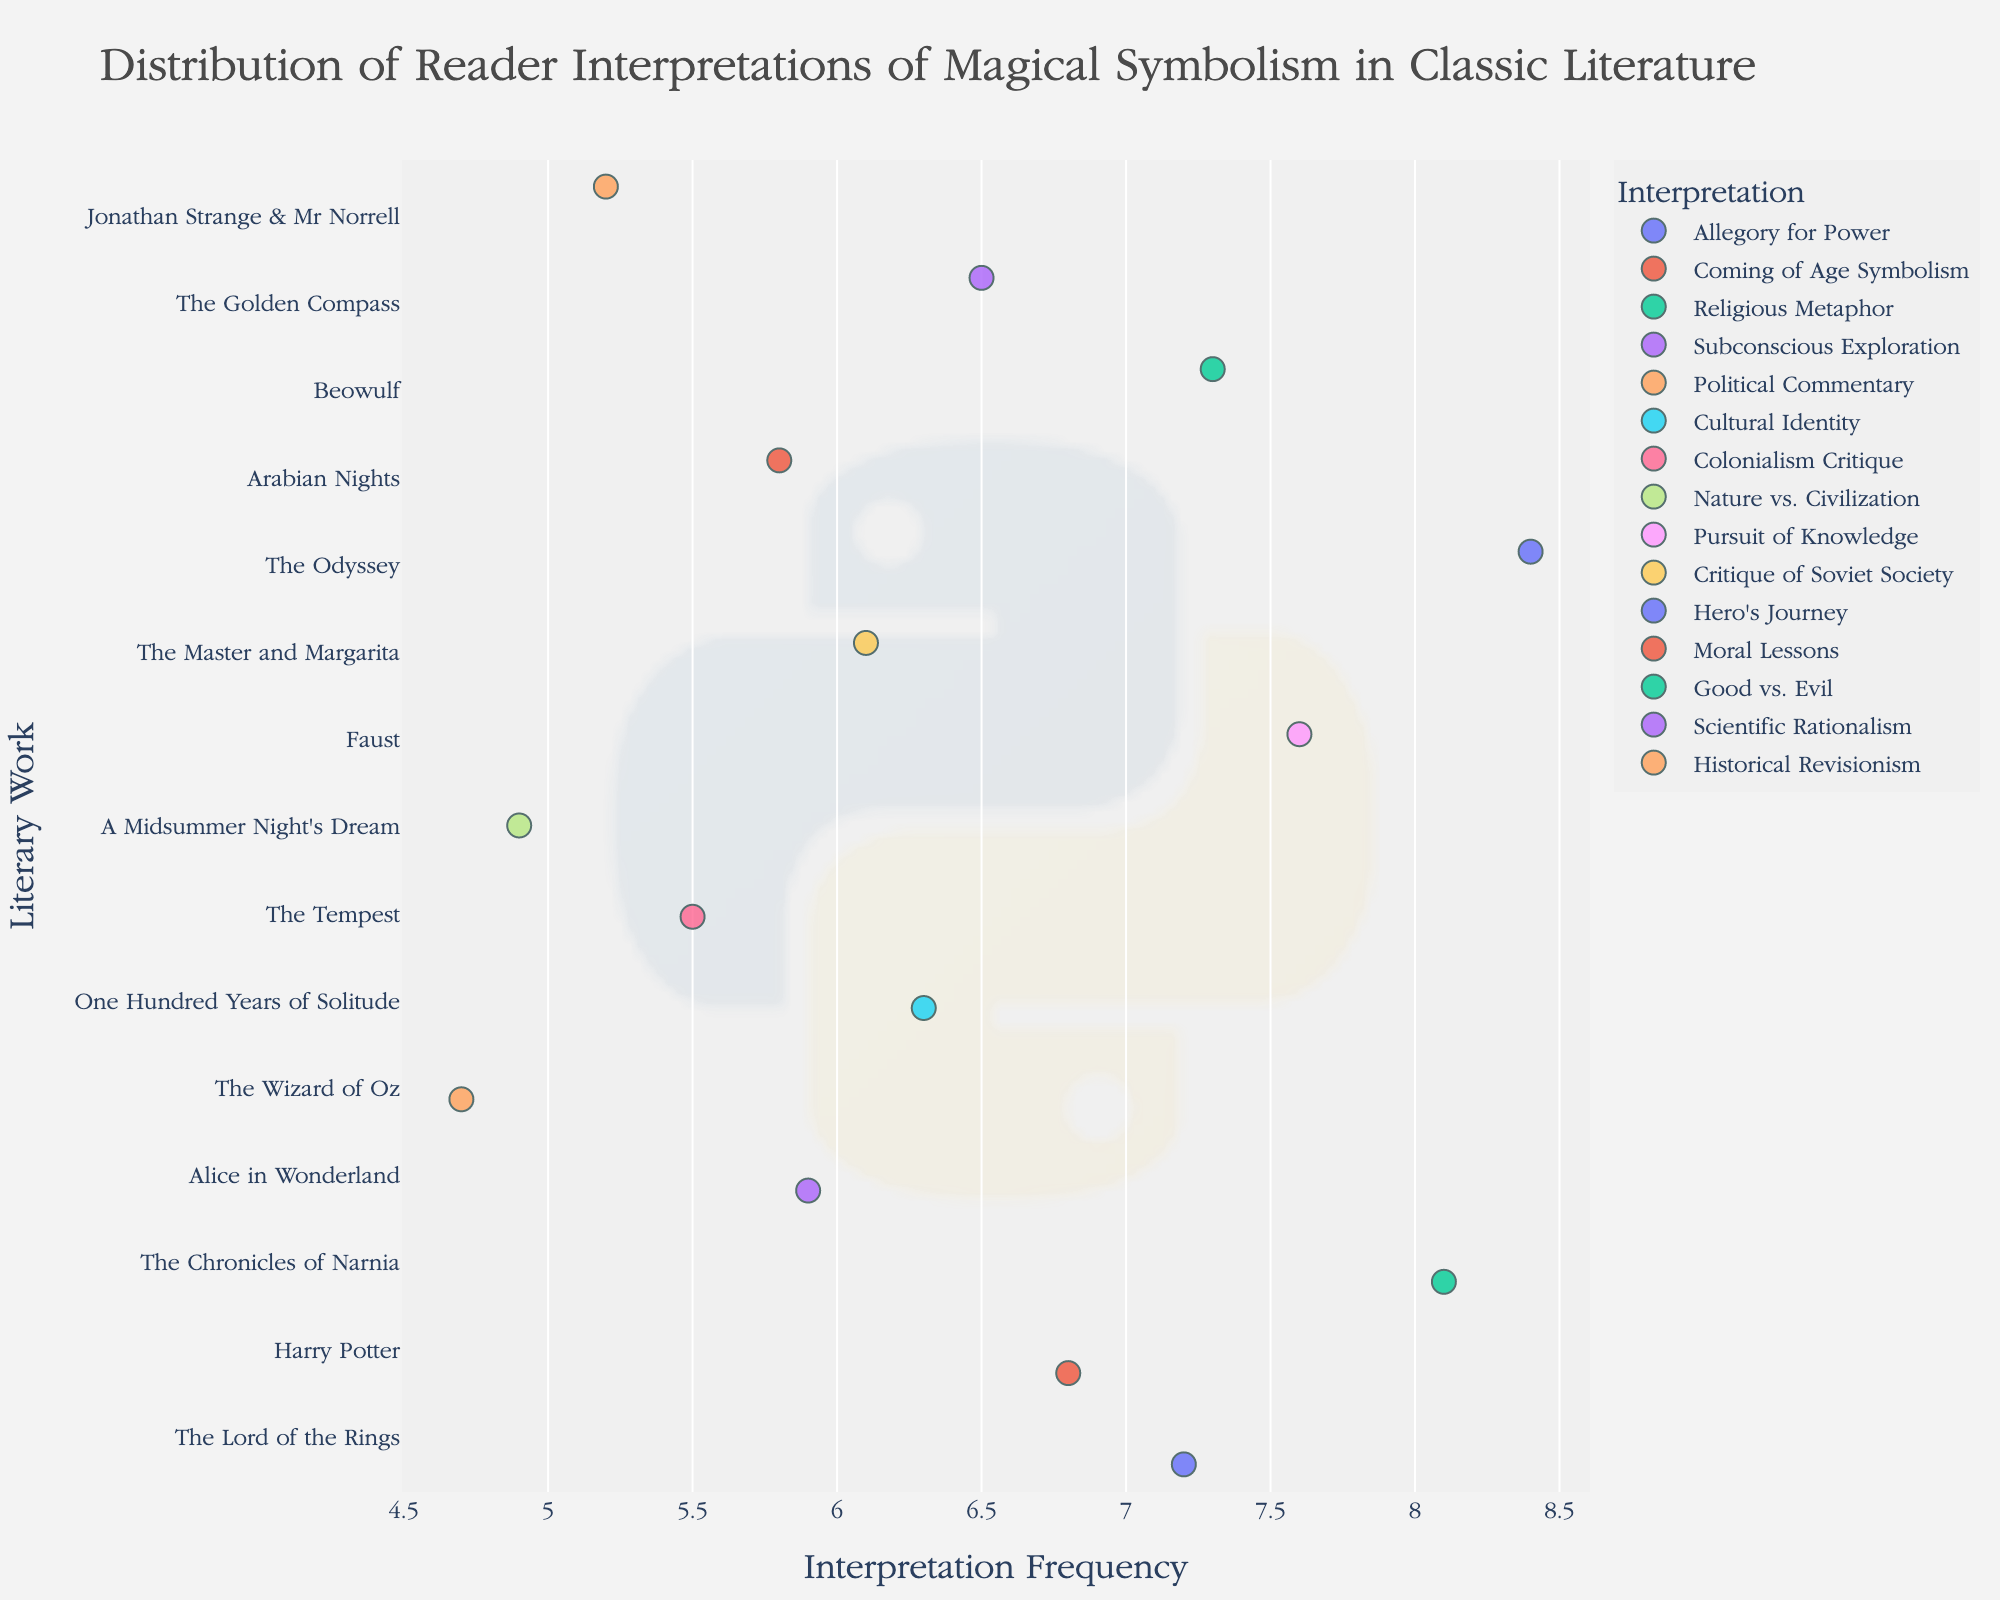What is the literary work with the highest frequency of interpretation? The figure shows a strip plot where the y-axis represents literary works and the x-axis represents the frequency of interpretation. By examining the values on the x-axis, "The Odyssey" has the highest frequency of interpretation at 8.4.
Answer: The Odyssey Which interpretation is most frequently associated with "The Chronicles of Narnia"? The plot indicates interpretations with color-coding and the y-axis lists "The Chronicles of Narnia." The data point at 8.1, which is the frequency for this book, corresponds to the "Religious Metaphor" interpretation.
Answer: Religious Metaphor How does the frequency of "Allegory for Power" in "The Lord of the Rings" compare to "Pursuit of Knowledge" in "Faust"? By comparing the x-axis values of "The Lord of the Rings" and "Faust," the former has a frequency of 7.2 while the latter is 7.6. Therefore, "Pursuit of Knowledge" in "Faust" is more frequent than "Allegory for Power" in "The Lord of the Rings".
Answer: "Pursuit of Knowledge" in "Faust" is more frequent Which literary work has the lowest frequency, and what is the corresponding interpretation? Observing the x-axis for the minimum value shows "The Wizard of Oz" having the lowest frequency at 4.7. The corresponding interpretation for this value is "Political Commentary."
Answer: The Wizard of Oz, Political Commentary How many literary works have a frequency of interpretation greater than 7? By looking at the x-axis and counting data points greater than 7: The Lord of the Rings (7.2), Faust (7.6), The Odyssey (8.4), and Beowulf (7.3). Four works fit this criterion.
Answer: Four What is the average frequency of interpretation for "Alice in Wonderland," "Arabian Nights," and "The Master and Margarita"? For "Alice in Wonderland" (5.9), "Arabian Nights" (5.8), and "The Master and Margarita" (6.1), sum their frequencies: (5.9 + 5.8 + 6.1) = 17.8. Dividing by 3: 17.8 / 3 = 5.93.
Answer: 5.93 Are there more books with an interpretation frequency above or below 6? Count the data points: Above 6: The Lord of the Rings (7.2), Harry Potter (6.8), The Chronicles of Narnia (8.1), One Hundred Years of Solitude (6.3), Faust (7.6), The Odyssey (8.4), Beowulf (7.3), The Golden Compass (6.5). Below 6: Alice in Wonderland (5.9), The Wizard of Oz (4.7), The Tempest (5.5), A Midsummer Night’s Dream (4.9), Arabian Nights (5.8), Jonathan Strange & Mr Norrell (5.2). 8 are above; 6 are below.
Answer: Above Which interpretation has a similar frequency in both "Harry Potter" and "One Hundred Years of Solitude"? Identifying the frequencies: "Harry Potter" (6.8) and "One Hundred Years of Solitude" (6.3); the values are close. "Harry Potter" is associated with "Coming of Age Symbolism," and "One Hundred Years of Solitude" with "Cultural Identity." Hence, no interpretation is shared, just similar frequencies.
Answer: No shared interpretation What is the range of interpretation frequencies for "A Midsummer Night's Dream"? The strip plot only shows one point per literary work. "A Midsummer Night’s Dream" has one frequency value of 4.9, so the range is 0.
Answer: 0 How many interpretations have a frequency between 6 and 7? Count the data points on the x-axis within the 6 to 7 range: Harry Potter (6.8), One Hundred Years of Solitude (6.3), The Master and Margarita (6.1), Beowulf (7.3 – but not considered as it exceeds 7), and The Golden Compass (6.5). Four fits this criterion.
Answer: Four 